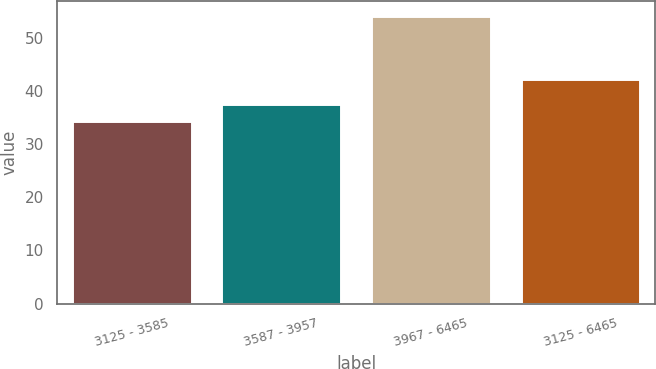<chart> <loc_0><loc_0><loc_500><loc_500><bar_chart><fcel>3125 - 3585<fcel>3587 - 3957<fcel>3967 - 6465<fcel>3125 - 6465<nl><fcel>34.33<fcel>37.51<fcel>54.18<fcel>42.21<nl></chart> 